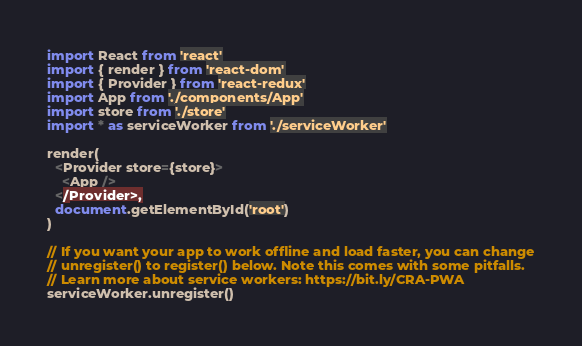Convert code to text. <code><loc_0><loc_0><loc_500><loc_500><_JavaScript_>import React from 'react'
import { render } from 'react-dom'
import { Provider } from 'react-redux'
import App from './components/App'
import store from './store'
import * as serviceWorker from './serviceWorker'

render(
  <Provider store={store}>
    <App />
  </Provider>,
  document.getElementById('root')
)

// If you want your app to work offline and load faster, you can change
// unregister() to register() below. Note this comes with some pitfalls.
// Learn more about service workers: https://bit.ly/CRA-PWA
serviceWorker.unregister()
</code> 